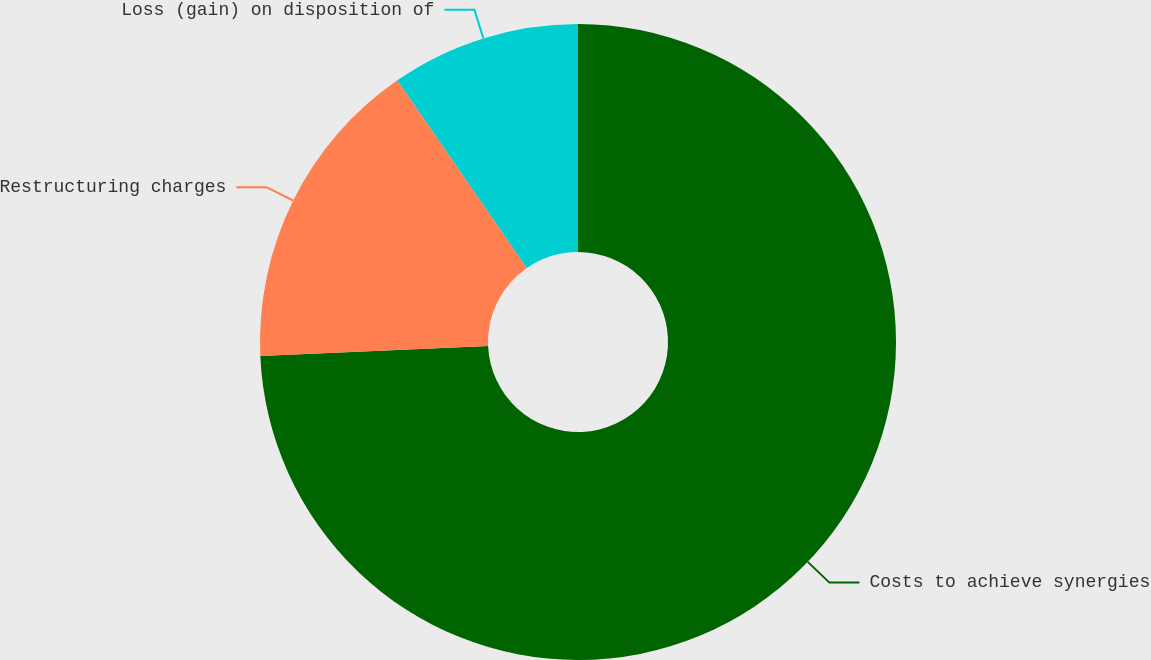Convert chart. <chart><loc_0><loc_0><loc_500><loc_500><pie_chart><fcel>Costs to achieve synergies<fcel>Restructuring charges<fcel>Loss (gain) on disposition of<nl><fcel>74.3%<fcel>16.08%<fcel>9.62%<nl></chart> 